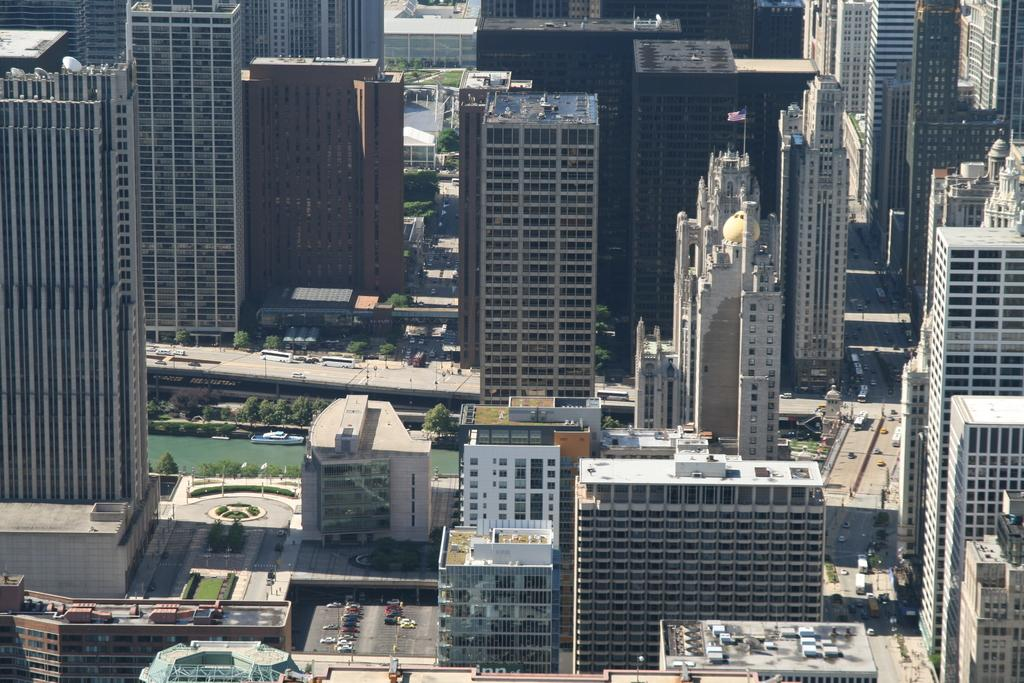Where was the picture taken? The picture was clicked outside. What can be seen in the foreground of the image? There is a group of vehicles in the foreground. What type of structures are visible in the image? Buildings and skyscrapers are visible in the image. What natural element is present in the image? There is a water body in the image. What type of vegetation is present in the image? Trees are present in the image. What type of canvas is being used to paint the basketball in the image? There is no canvas or basketball present in the image. What is the calculator used for in the image? There is no calculator present in the image. 